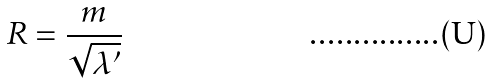Convert formula to latex. <formula><loc_0><loc_0><loc_500><loc_500>R = { \frac { m } { \sqrt { \lambda ^ { \prime } } } }</formula> 